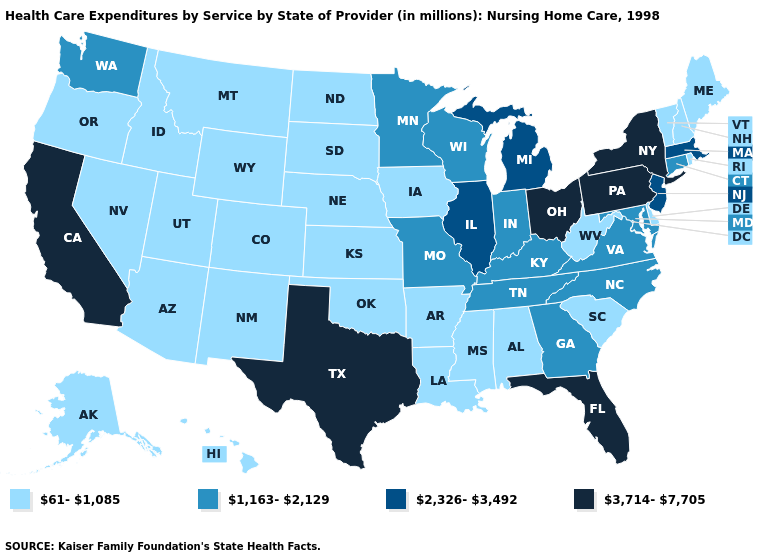Which states have the highest value in the USA?
Keep it brief. California, Florida, New York, Ohio, Pennsylvania, Texas. Among the states that border Oklahoma , which have the highest value?
Give a very brief answer. Texas. Does the first symbol in the legend represent the smallest category?
Give a very brief answer. Yes. What is the value of West Virginia?
Short answer required. 61-1,085. What is the value of California?
Be succinct. 3,714-7,705. Name the states that have a value in the range 2,326-3,492?
Keep it brief. Illinois, Massachusetts, Michigan, New Jersey. Name the states that have a value in the range 2,326-3,492?
Keep it brief. Illinois, Massachusetts, Michigan, New Jersey. How many symbols are there in the legend?
Be succinct. 4. Does Nebraska have the lowest value in the USA?
Answer briefly. Yes. Does the first symbol in the legend represent the smallest category?
Be succinct. Yes. Which states have the lowest value in the USA?
Answer briefly. Alabama, Alaska, Arizona, Arkansas, Colorado, Delaware, Hawaii, Idaho, Iowa, Kansas, Louisiana, Maine, Mississippi, Montana, Nebraska, Nevada, New Hampshire, New Mexico, North Dakota, Oklahoma, Oregon, Rhode Island, South Carolina, South Dakota, Utah, Vermont, West Virginia, Wyoming. What is the value of New Hampshire?
Give a very brief answer. 61-1,085. Does the first symbol in the legend represent the smallest category?
Be succinct. Yes. What is the value of Massachusetts?
Short answer required. 2,326-3,492. 